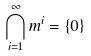Convert formula to latex. <formula><loc_0><loc_0><loc_500><loc_500>\bigcap _ { i = 1 } ^ { \infty } m ^ { i } = \{ 0 \}</formula> 